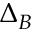<formula> <loc_0><loc_0><loc_500><loc_500>\Delta _ { B }</formula> 